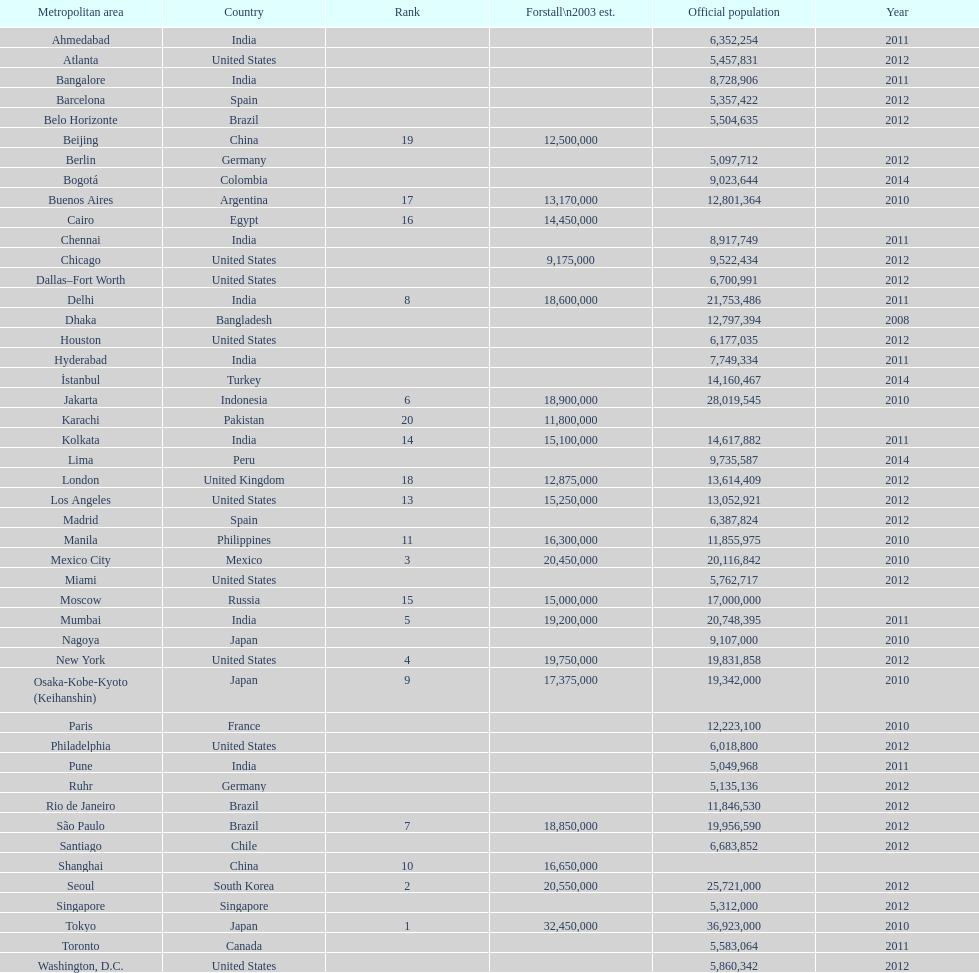What is the population listed immediately before 5,357,422? 8,728,906. 